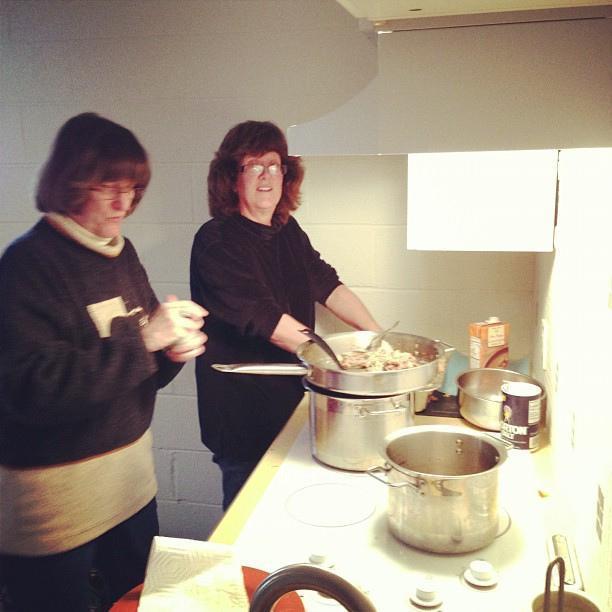How many stock pots are on the counter?
Give a very brief answer. 2. How many people in this picture?
Give a very brief answer. 2. How many people are in the picture?
Give a very brief answer. 2. How many elephants can be seen?
Give a very brief answer. 0. 